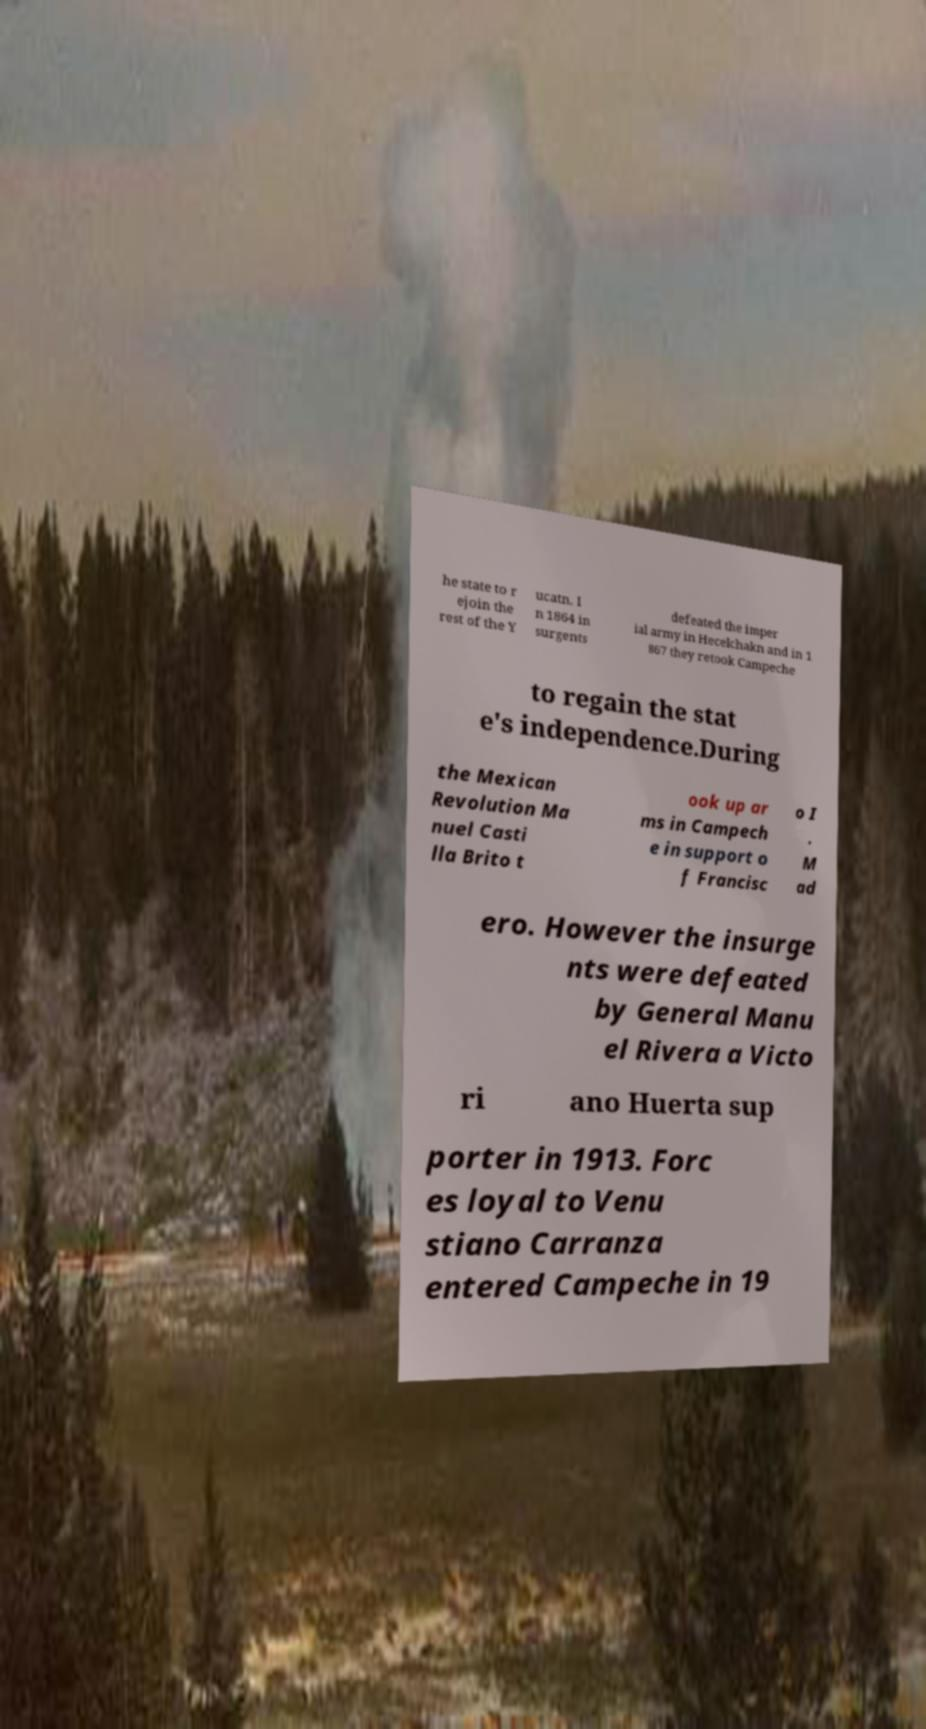Please identify and transcribe the text found in this image. he state to r ejoin the rest of the Y ucatn. I n 1864 in surgents defeated the imper ial army in Hecelchakn and in 1 867 they retook Campeche to regain the stat e's independence.During the Mexican Revolution Ma nuel Casti lla Brito t ook up ar ms in Campech e in support o f Francisc o I . M ad ero. However the insurge nts were defeated by General Manu el Rivera a Victo ri ano Huerta sup porter in 1913. Forc es loyal to Venu stiano Carranza entered Campeche in 19 